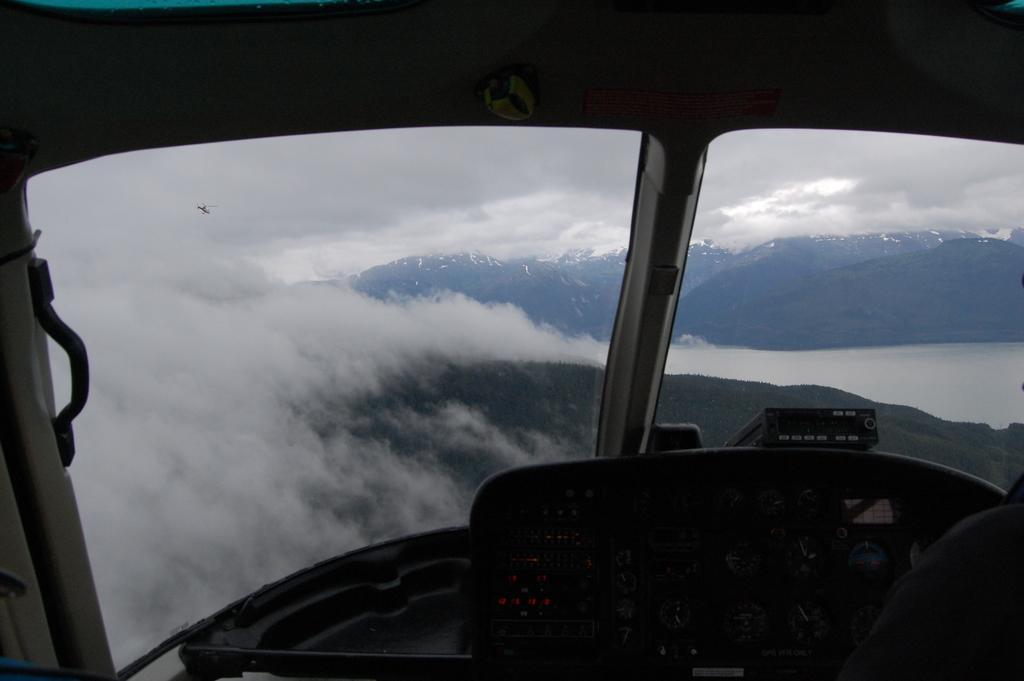In one or two sentences, can you explain what this image depicts? In this picture I can see the inside view of the plane. In the background I can see the mountains, sky and clouds. On the right I can see the river. In the bottom right corner I can see the person's shoulder who is wearing shirt. In the top left there is a plane which is flying above the clouds. 